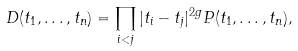Convert formula to latex. <formula><loc_0><loc_0><loc_500><loc_500>D ( t _ { 1 } , \dots , t _ { n } ) = \prod _ { i < j } | t _ { i } - t _ { j } | ^ { 2 g } P ( t _ { 1 } , \dots , t _ { n } ) ,</formula> 